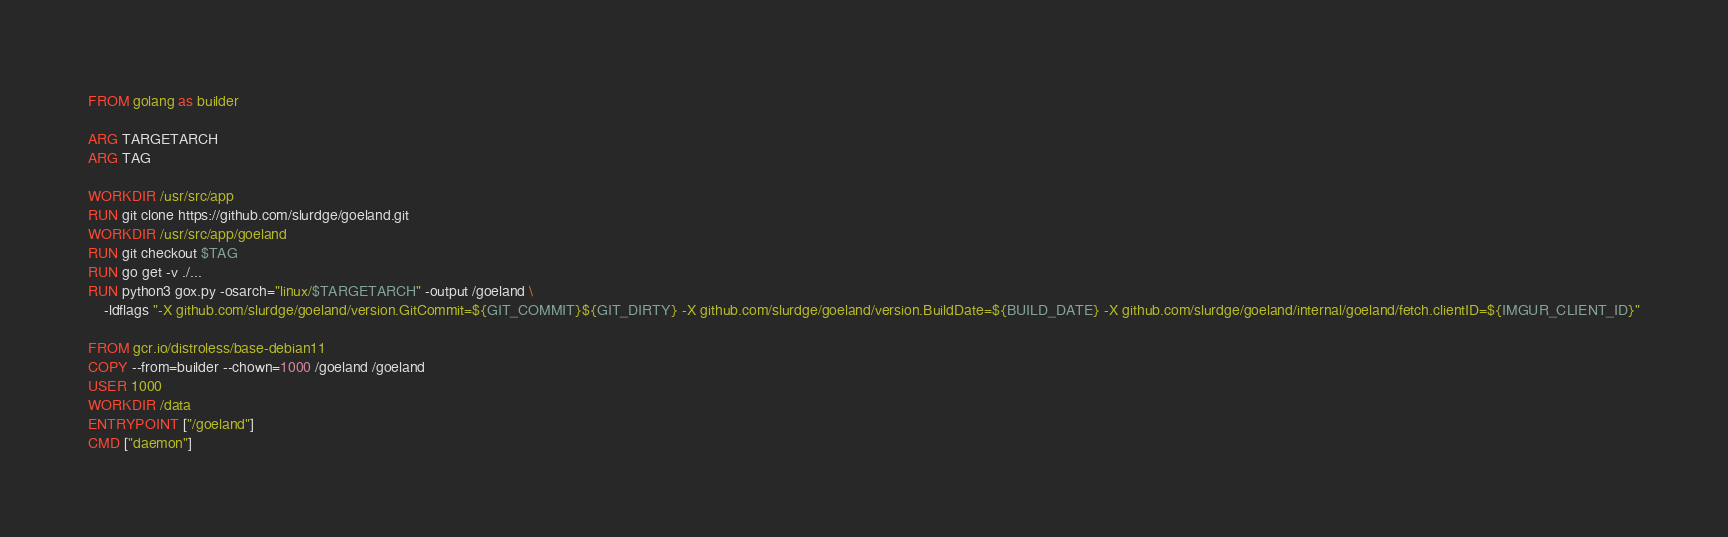Convert code to text. <code><loc_0><loc_0><loc_500><loc_500><_Dockerfile_>FROM golang as builder

ARG TARGETARCH
ARG TAG

WORKDIR /usr/src/app
RUN git clone https://github.com/slurdge/goeland.git
WORKDIR /usr/src/app/goeland
RUN git checkout $TAG
RUN go get -v ./...
RUN python3 gox.py -osarch="linux/$TARGETARCH" -output /goeland \
    -ldflags "-X github.com/slurdge/goeland/version.GitCommit=${GIT_COMMIT}${GIT_DIRTY} -X github.com/slurdge/goeland/version.BuildDate=${BUILD_DATE} -X github.com/slurdge/goeland/internal/goeland/fetch.clientID=${IMGUR_CLIENT_ID}"

FROM gcr.io/distroless/base-debian11
COPY --from=builder --chown=1000 /goeland /goeland
USER 1000
WORKDIR /data
ENTRYPOINT ["/goeland"]
CMD ["daemon"]
</code> 